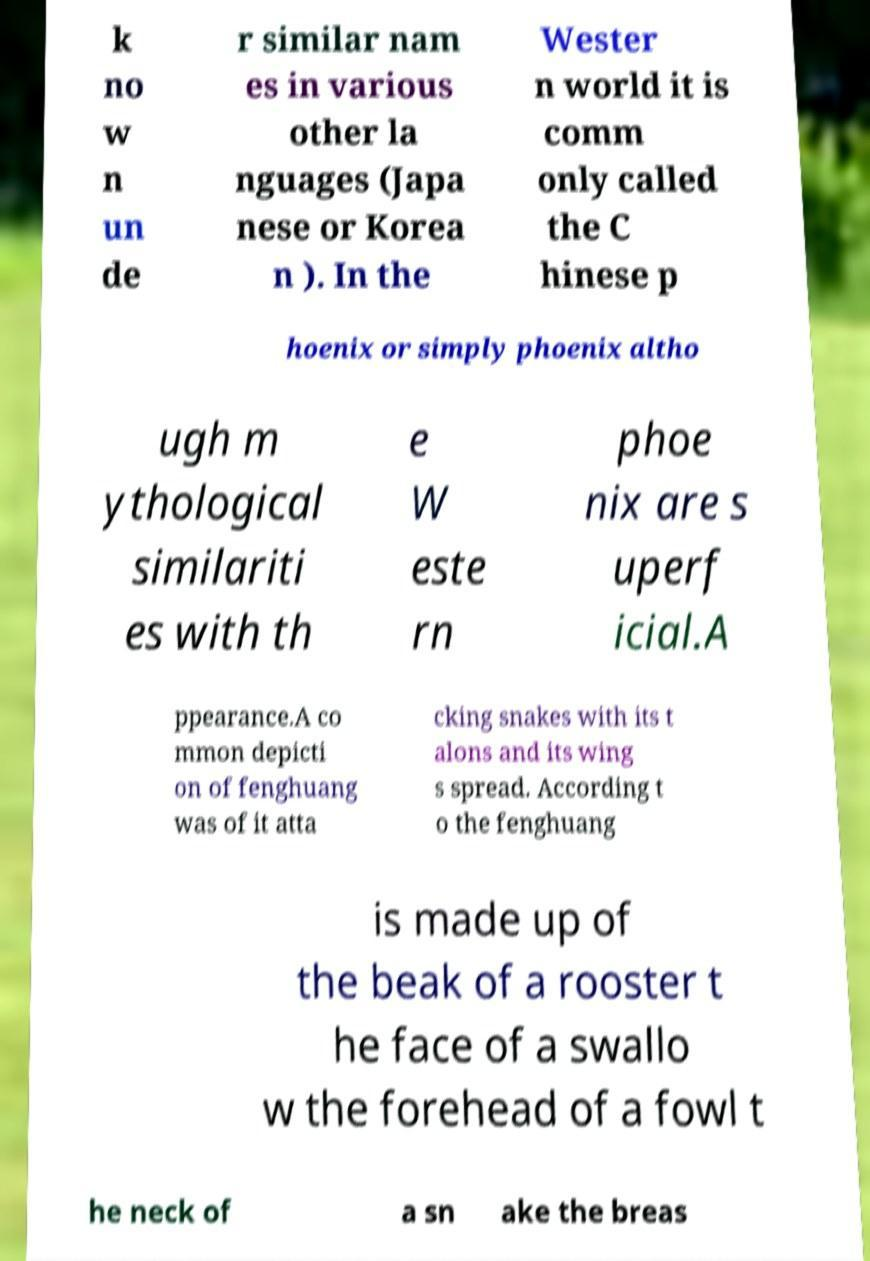For documentation purposes, I need the text within this image transcribed. Could you provide that? k no w n un de r similar nam es in various other la nguages (Japa nese or Korea n ). In the Wester n world it is comm only called the C hinese p hoenix or simply phoenix altho ugh m ythological similariti es with th e W este rn phoe nix are s uperf icial.A ppearance.A co mmon depicti on of fenghuang was of it atta cking snakes with its t alons and its wing s spread. According t o the fenghuang is made up of the beak of a rooster t he face of a swallo w the forehead of a fowl t he neck of a sn ake the breas 